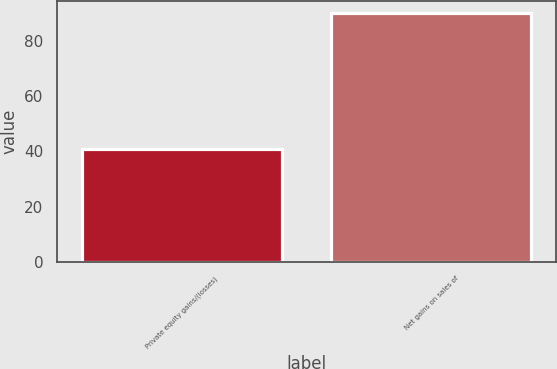<chart> <loc_0><loc_0><loc_500><loc_500><bar_chart><fcel>Private equity gains/(losses)<fcel>Net gains on sales of<nl><fcel>41<fcel>90<nl></chart> 